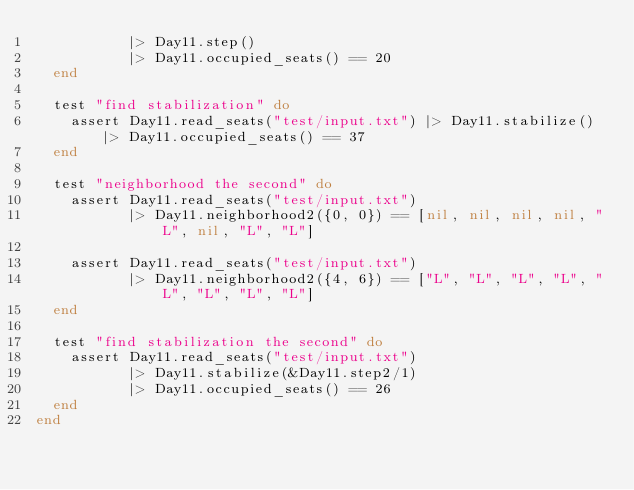<code> <loc_0><loc_0><loc_500><loc_500><_Elixir_>           |> Day11.step()
           |> Day11.occupied_seats() == 20
  end

  test "find stabilization" do
    assert Day11.read_seats("test/input.txt") |> Day11.stabilize() |> Day11.occupied_seats() == 37
  end

  test "neighborhood the second" do
    assert Day11.read_seats("test/input.txt")
           |> Day11.neighborhood2({0, 0}) == [nil, nil, nil, nil, "L", nil, "L", "L"]

    assert Day11.read_seats("test/input.txt")
           |> Day11.neighborhood2({4, 6}) == ["L", "L", "L", "L", "L", "L", "L", "L"]
  end

  test "find stabilization the second" do
    assert Day11.read_seats("test/input.txt")
           |> Day11.stabilize(&Day11.step2/1)
           |> Day11.occupied_seats() == 26
  end
end
</code> 